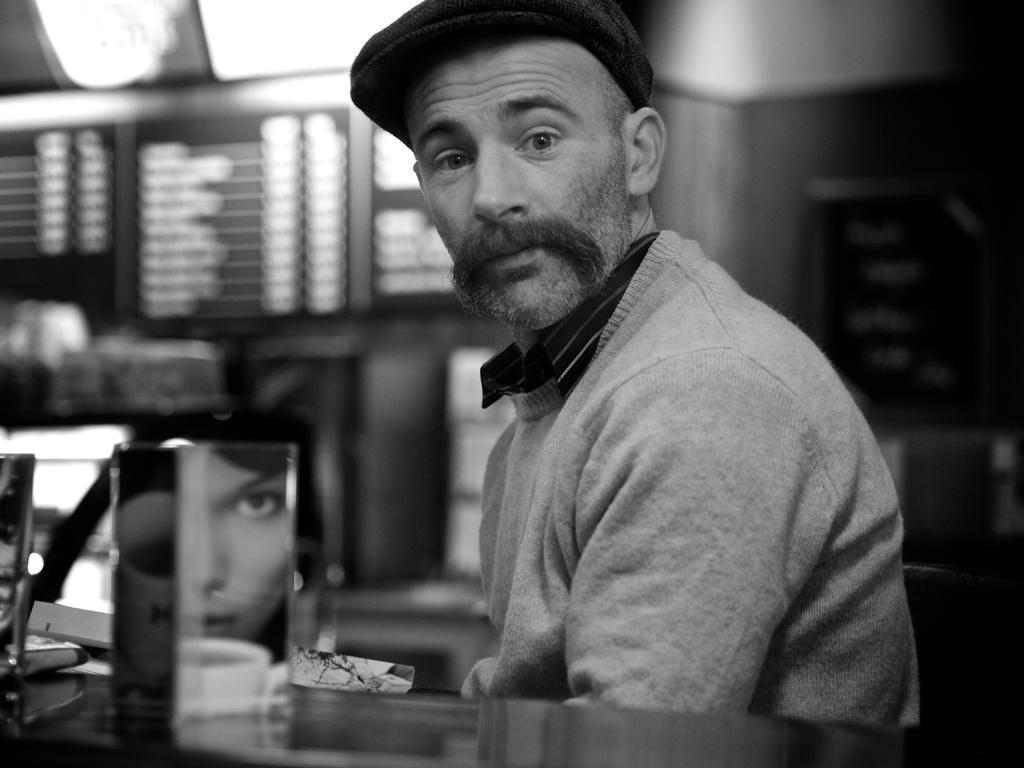In one or two sentences, can you explain what this image depicts? This is black and white picture,there is a man,in front of this man we can see glass on the surface,in this class we can see a person face and cup. In the background it is blur. 